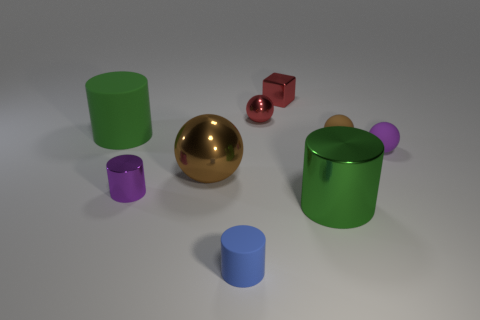Is the number of small blue rubber things on the right side of the small blue matte cylinder the same as the number of big brown metallic things behind the tiny purple cylinder?
Give a very brief answer. No. How many green things are shiny balls or matte cylinders?
Your answer should be very brief. 1. What number of brown balls are the same size as the green shiny cylinder?
Your answer should be very brief. 1. What color is the tiny object that is to the right of the tiny red metal ball and behind the tiny brown sphere?
Make the answer very short. Red. Are there more rubber cylinders left of the large brown object than metal blocks?
Your response must be concise. No. Are there any large green metal objects?
Keep it short and to the point. Yes. Does the shiny cube have the same color as the small metallic ball?
Your response must be concise. Yes. What number of tiny things are matte cylinders or purple cylinders?
Your answer should be very brief. 2. Is there any other thing of the same color as the small rubber cylinder?
Offer a very short reply. No. There is a purple thing that is made of the same material as the tiny brown ball; what is its shape?
Your response must be concise. Sphere. 